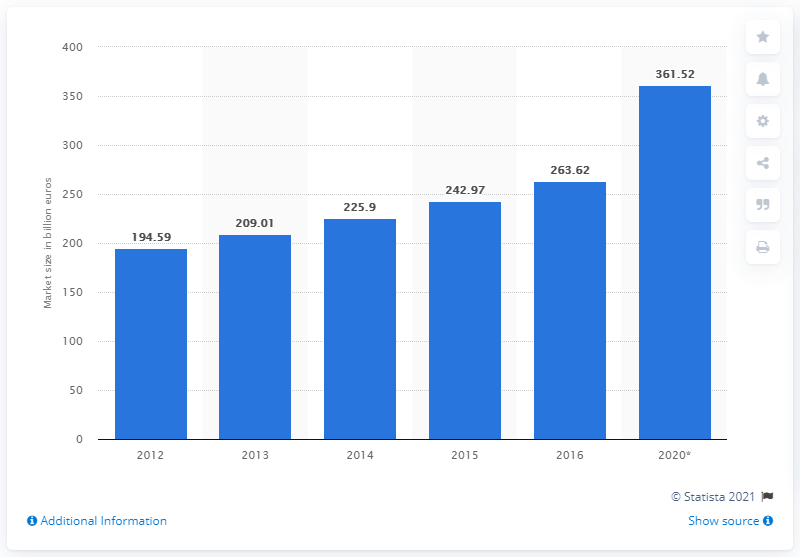Give some essential details in this illustration. In 2016, the global express parcel market was valued at approximately 263.62 billion US dollars. 